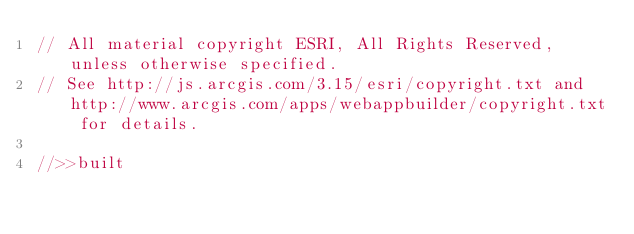<code> <loc_0><loc_0><loc_500><loc_500><_JavaScript_>// All material copyright ESRI, All Rights Reserved, unless otherwise specified.
// See http://js.arcgis.com/3.15/esri/copyright.txt and http://www.arcgis.com/apps/webappbuilder/copyright.txt for details.
//>>built</code> 